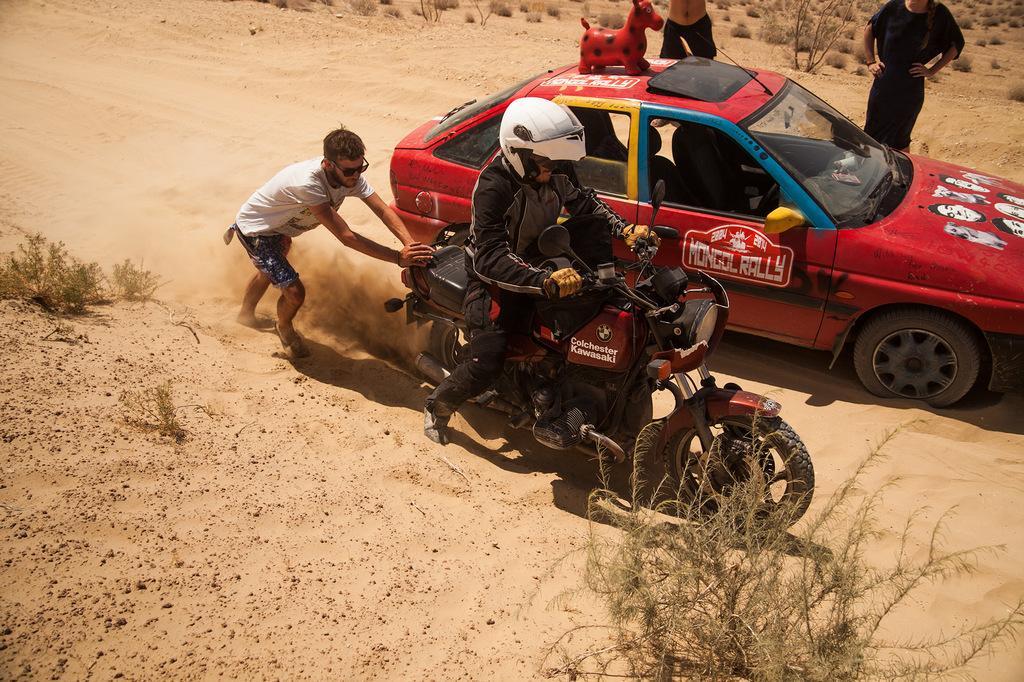Could you give a brief overview of what you see in this image? A Man is trying to ride a motorcycle ,Another man is pushing the bike from behind. There is red color car beside the bike. There are two people standing beside the car. 